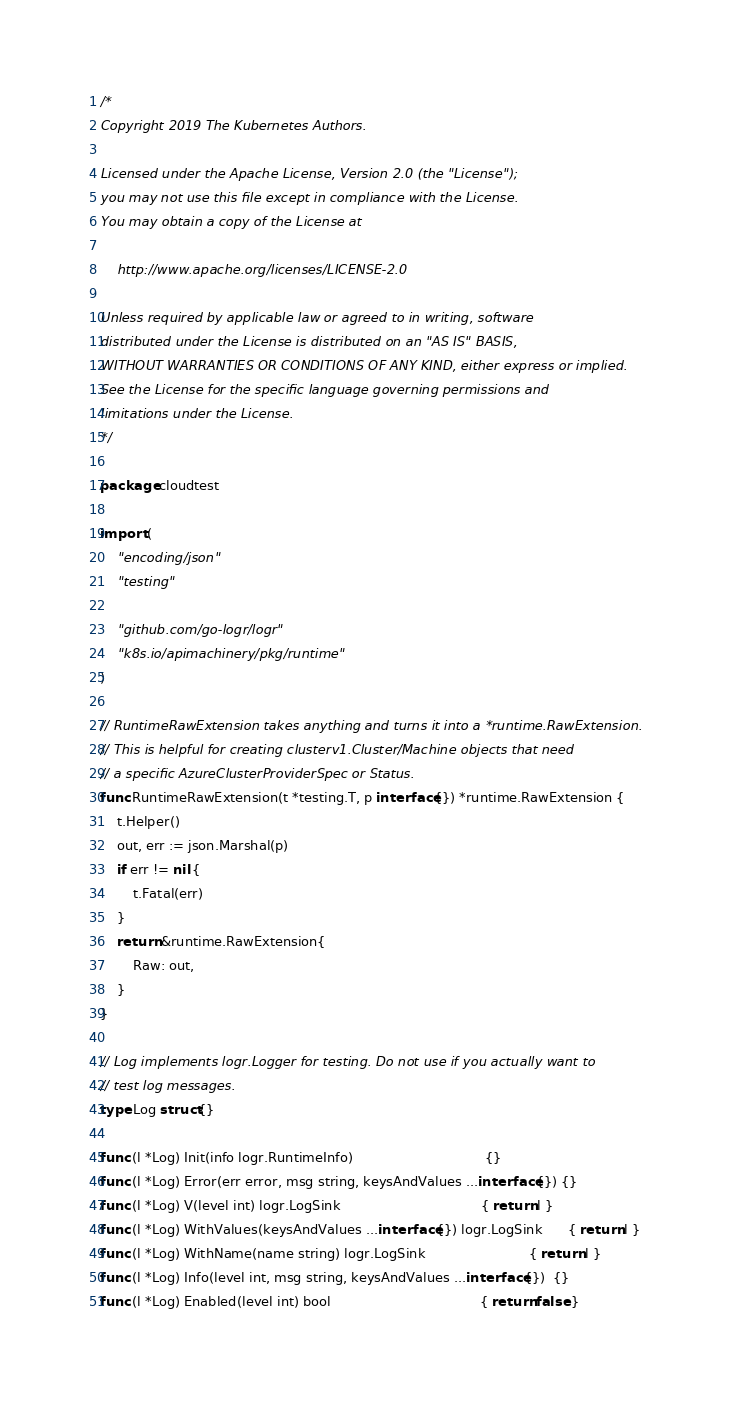Convert code to text. <code><loc_0><loc_0><loc_500><loc_500><_Go_>/*
Copyright 2019 The Kubernetes Authors.

Licensed under the Apache License, Version 2.0 (the "License");
you may not use this file except in compliance with the License.
You may obtain a copy of the License at

    http://www.apache.org/licenses/LICENSE-2.0

Unless required by applicable law or agreed to in writing, software
distributed under the License is distributed on an "AS IS" BASIS,
WITHOUT WARRANTIES OR CONDITIONS OF ANY KIND, either express or implied.
See the License for the specific language governing permissions and
limitations under the License.
*/

package cloudtest

import (
	"encoding/json"
	"testing"

	"github.com/go-logr/logr"
	"k8s.io/apimachinery/pkg/runtime"
)

// RuntimeRawExtension takes anything and turns it into a *runtime.RawExtension.
// This is helpful for creating clusterv1.Cluster/Machine objects that need
// a specific AzureClusterProviderSpec or Status.
func RuntimeRawExtension(t *testing.T, p interface{}) *runtime.RawExtension {
	t.Helper()
	out, err := json.Marshal(p)
	if err != nil {
		t.Fatal(err)
	}
	return &runtime.RawExtension{
		Raw: out,
	}
}

// Log implements logr.Logger for testing. Do not use if you actually want to
// test log messages.
type Log struct{}

func (l *Log) Init(info logr.RuntimeInfo)                                {}
func (l *Log) Error(err error, msg string, keysAndValues ...interface{}) {}
func (l *Log) V(level int) logr.LogSink                                  { return l }
func (l *Log) WithValues(keysAndValues ...interface{}) logr.LogSink      { return l }
func (l *Log) WithName(name string) logr.LogSink                         { return l }
func (l *Log) Info(level int, msg string, keysAndValues ...interface{})  {}
func (l *Log) Enabled(level int) bool                                    { return false }
</code> 